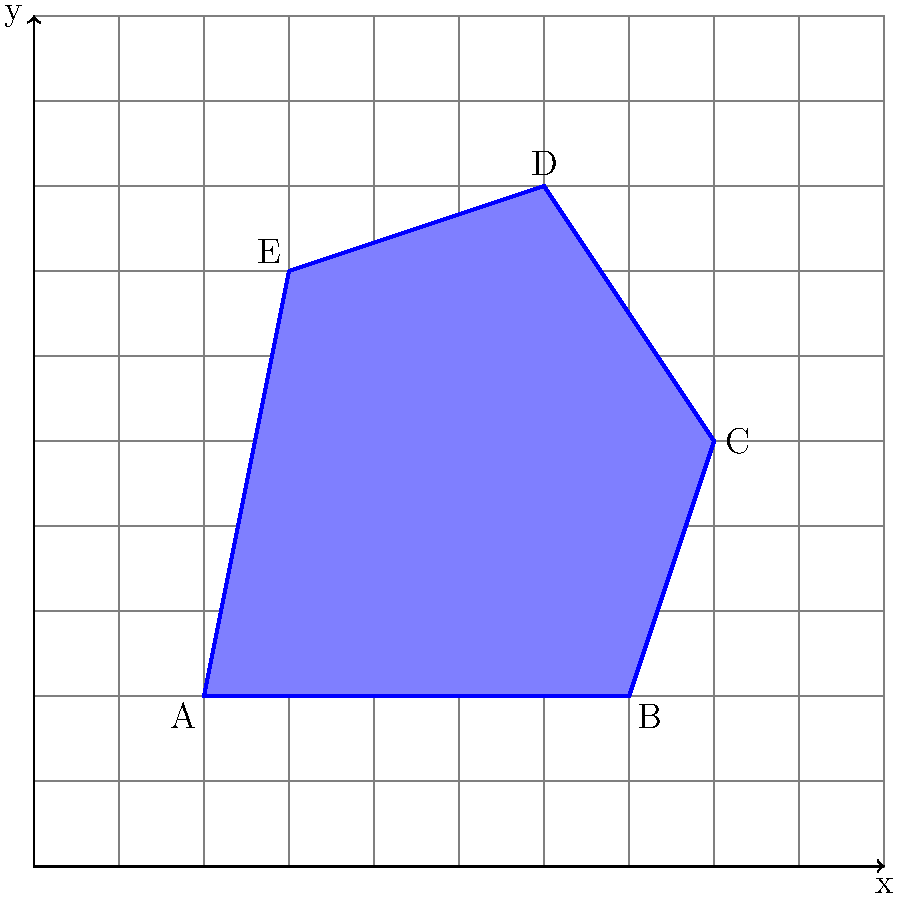В качестве дизайнера вам необходимо рассчитать площадь нерегулярного многоугольника ABCDE, изображенного на сетке. Каждая клетка сетки имеет размер 1x1 единицу. Какова приблизительная площадь многоугольника в квадратных единицах? Для расчета приблизительной площади нерегулярного многоугольника с помощью наложенной сетки выполним следующие шаги:

1) Подсчитаем полные клетки внутри многоугольника:
   Полных клеток примерно 25.

2) Оценим частичные клетки:
   - Вдоль границ многоугольника есть около 16 частичных клеток.
   - В среднем, каждая частичная клетка составляет примерно половину полной клетки.
   - Таким образом, частичные клетки эквивалентны примерно 8 полным клеткам (16 * 0.5).

3) Сложим полные и частичные клетки:
   $$25 + 8 = 33$$

4) Так как каждая клетка имеет площадь 1 квадратную единицу, общая приблизительная площадь многоугольника составляет 33 квадратных единицы.

Обратите внимание, что это приближенный метод, и точность зависит от детальности сетки и точности оценки частичных клеток.
Answer: 33 квадратные единицы 